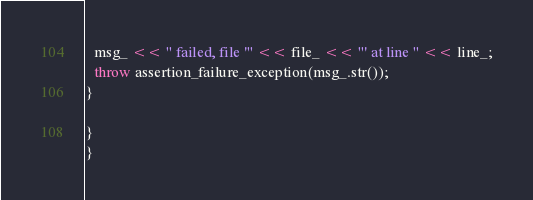<code> <loc_0><loc_0><loc_500><loc_500><_C++_>  msg_ << " failed, file '" << file_ << "' at line " << line_;
  throw assertion_failure_exception(msg_.str());
}

}
}</code> 